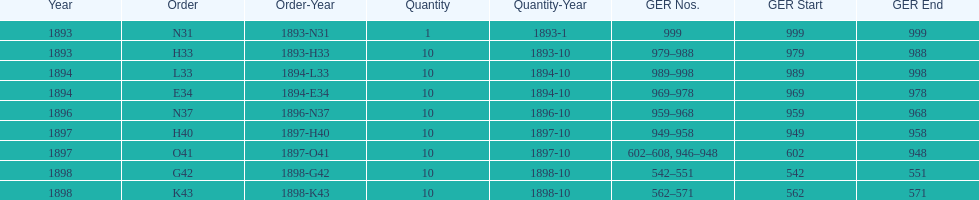Between 1893 and 1898, which year was devoid of an order? 1895. 